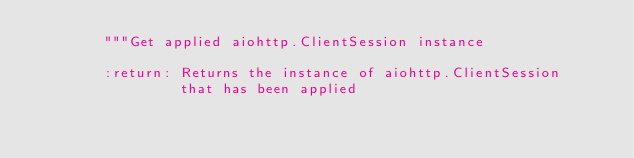<code> <loc_0><loc_0><loc_500><loc_500><_Python_>        """Get applied aiohttp.ClientSession instance
        
        :return: Returns the instance of aiohttp.ClientSession
                 that has been applied</code> 